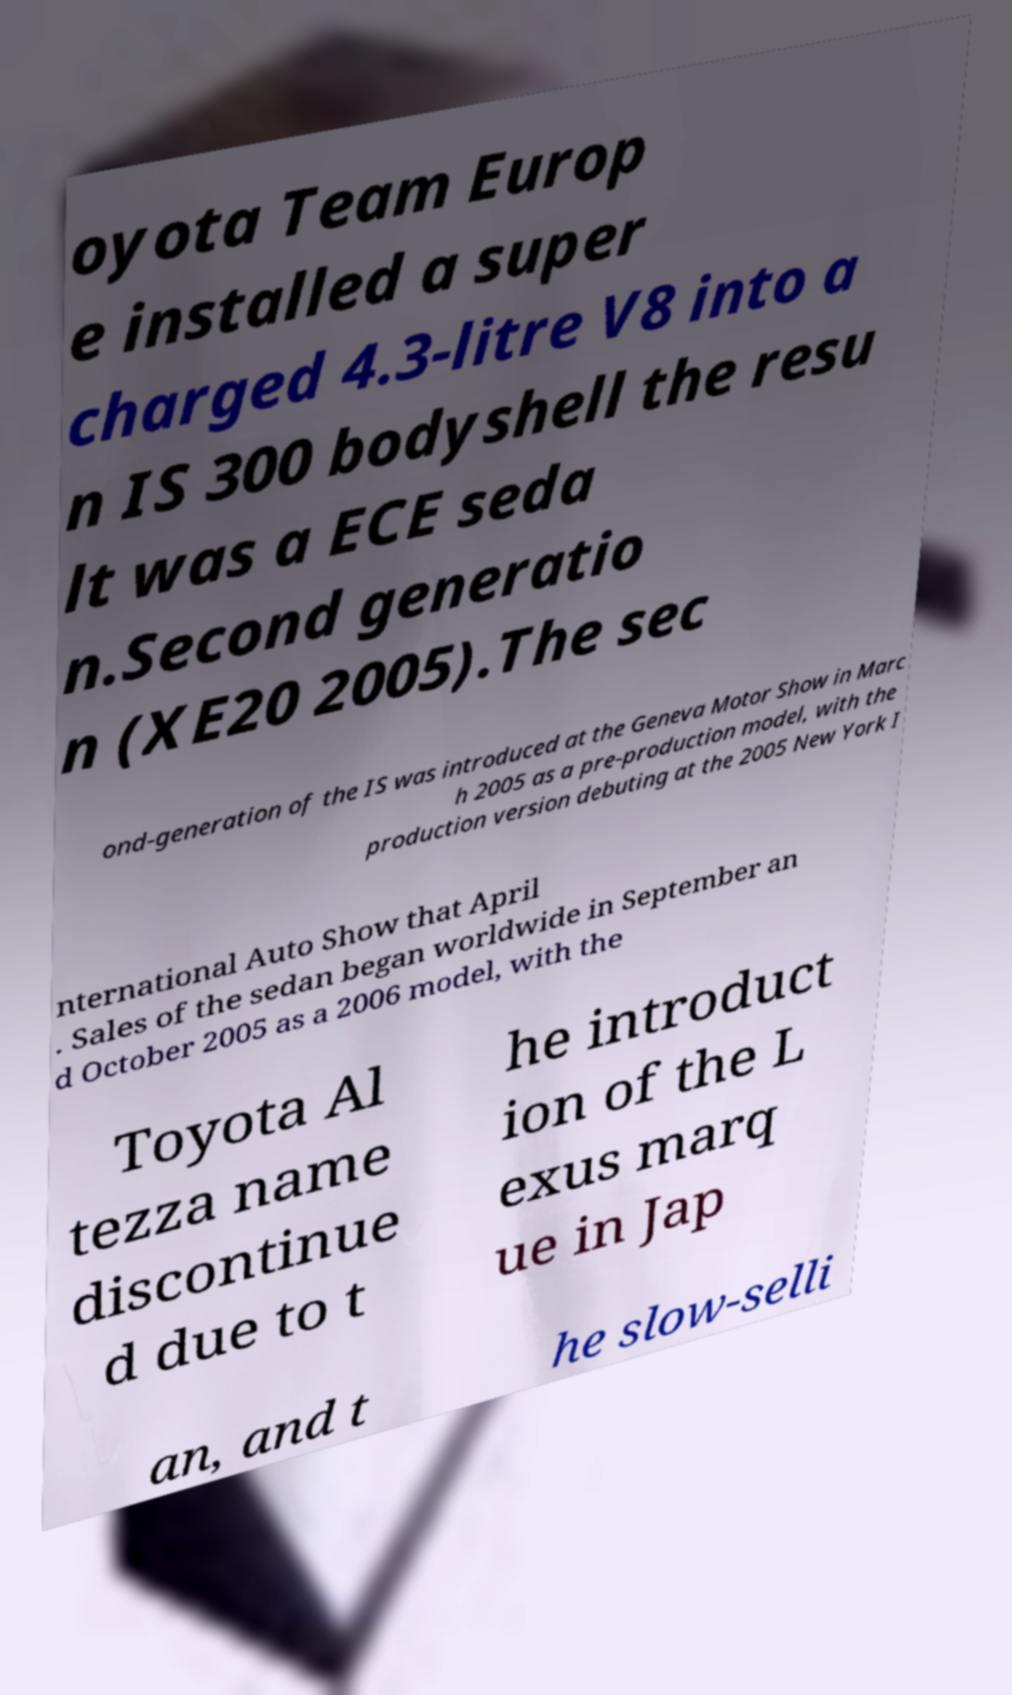There's text embedded in this image that I need extracted. Can you transcribe it verbatim? oyota Team Europ e installed a super charged 4.3-litre V8 into a n IS 300 bodyshell the resu lt was a ECE seda n.Second generatio n (XE20 2005).The sec ond-generation of the IS was introduced at the Geneva Motor Show in Marc h 2005 as a pre-production model, with the production version debuting at the 2005 New York I nternational Auto Show that April . Sales of the sedan began worldwide in September an d October 2005 as a 2006 model, with the Toyota Al tezza name discontinue d due to t he introduct ion of the L exus marq ue in Jap an, and t he slow-selli 